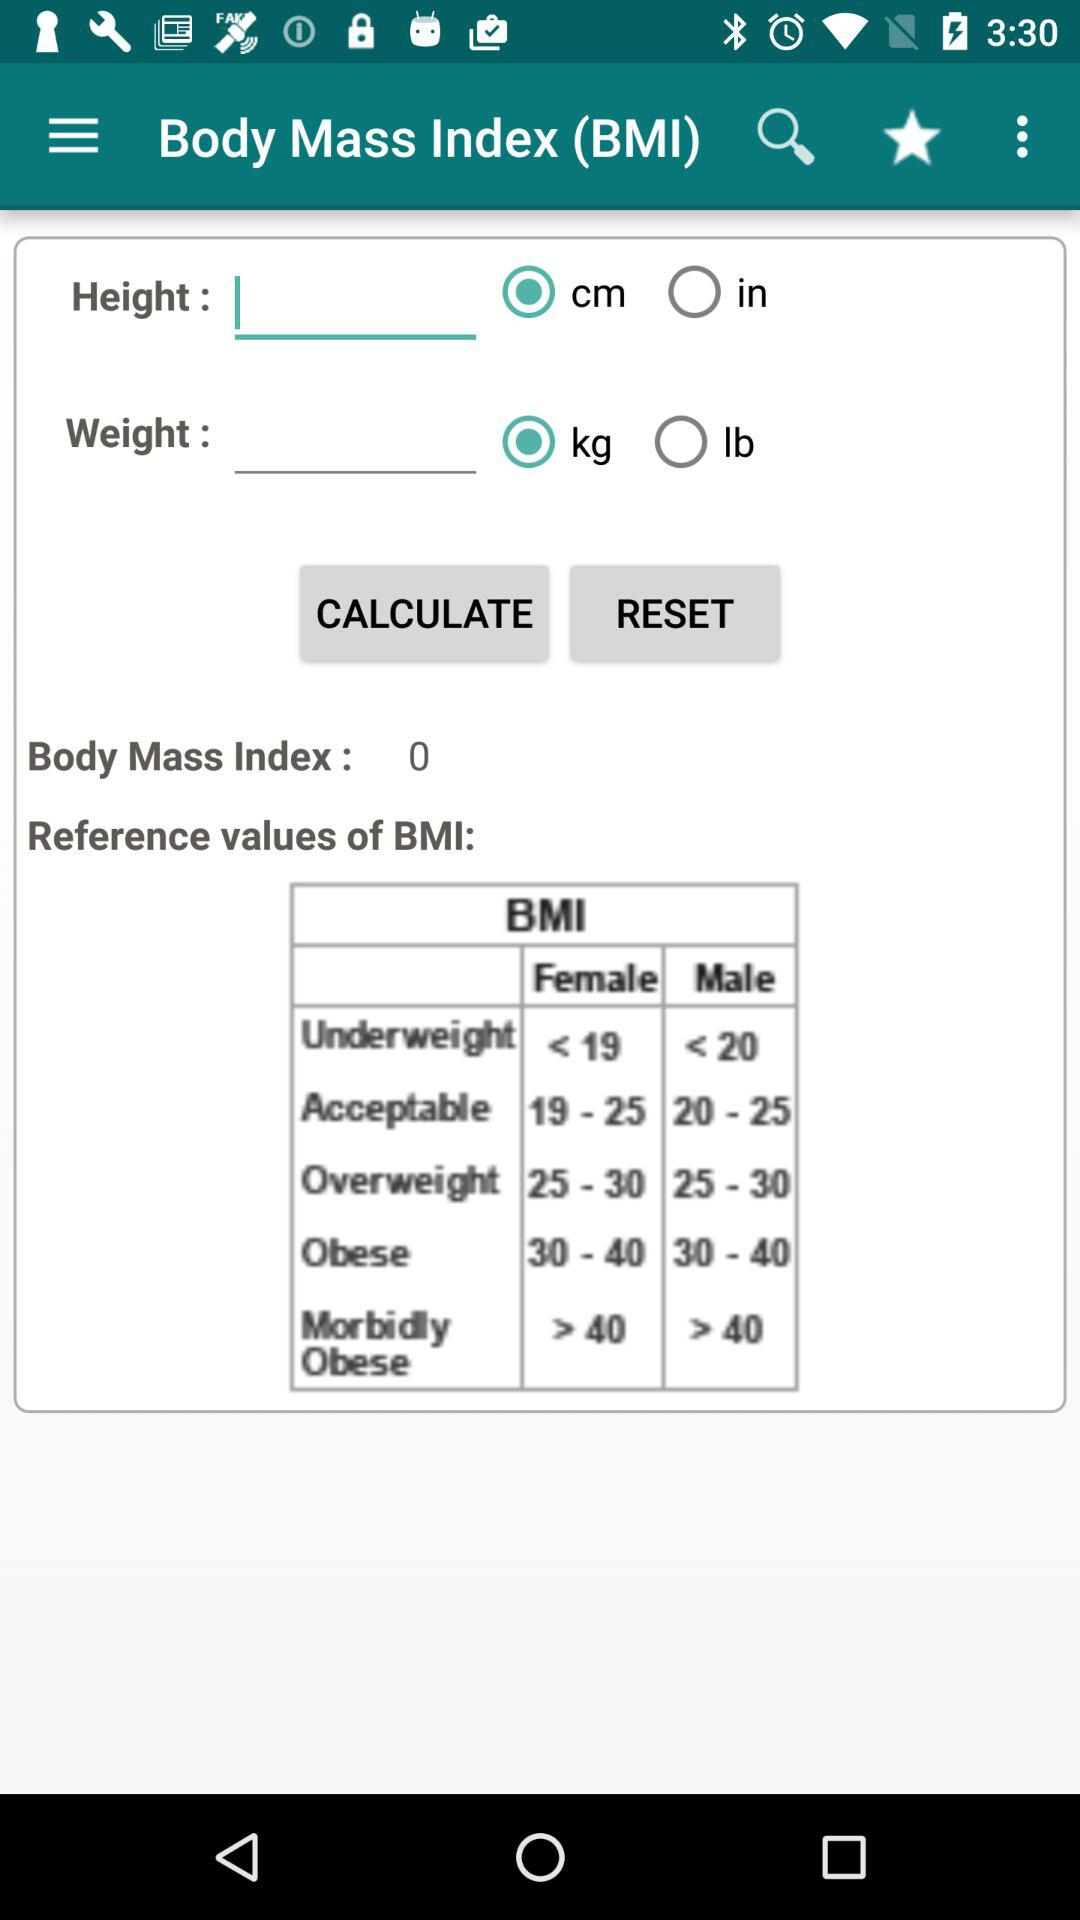How many options are there for the measurement units of height?
Answer the question using a single word or phrase. 2 